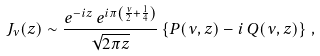Convert formula to latex. <formula><loc_0><loc_0><loc_500><loc_500>J _ { \nu } ( z ) \sim \frac { e ^ { - i z } \, e ^ { i \pi \left ( \frac { \nu } { 2 } + \frac { 1 } { 4 } \right ) } } { \sqrt { 2 \pi z } } \left \{ P ( \nu , z ) - i \, Q ( \nu , z ) \right \} \, ,</formula> 